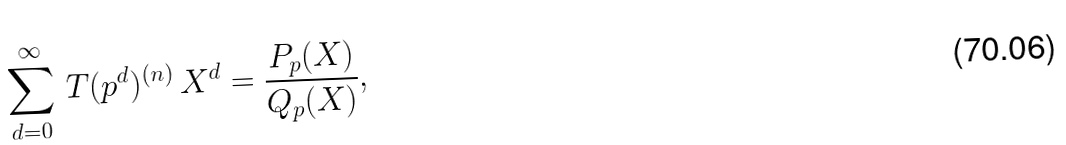<formula> <loc_0><loc_0><loc_500><loc_500>\sum _ { d = 0 } ^ { \infty } \, T ( p ^ { d } ) ^ { ( n ) } \, X ^ { d } = \frac { P _ { p } ( X ) } { Q _ { p } ( X ) } ,</formula> 